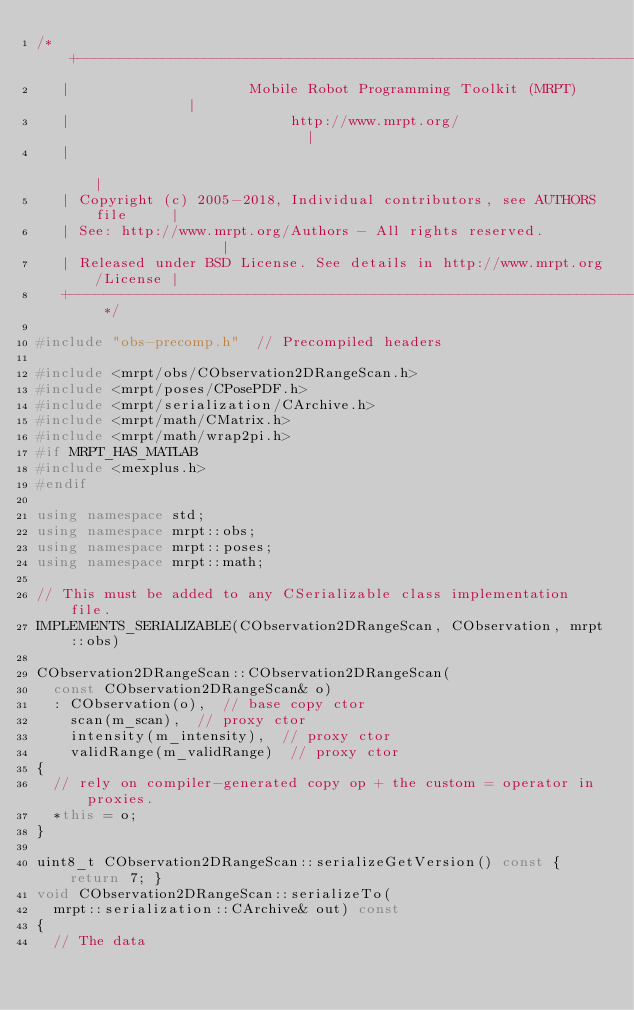Convert code to text. <code><loc_0><loc_0><loc_500><loc_500><_C++_>/* +------------------------------------------------------------------------+
   |                     Mobile Robot Programming Toolkit (MRPT)            |
   |                          http://www.mrpt.org/                          |
   |                                                                        |
   | Copyright (c) 2005-2018, Individual contributors, see AUTHORS file     |
   | See: http://www.mrpt.org/Authors - All rights reserved.                |
   | Released under BSD License. See details in http://www.mrpt.org/License |
   +------------------------------------------------------------------------+ */

#include "obs-precomp.h"  // Precompiled headers

#include <mrpt/obs/CObservation2DRangeScan.h>
#include <mrpt/poses/CPosePDF.h>
#include <mrpt/serialization/CArchive.h>
#include <mrpt/math/CMatrix.h>
#include <mrpt/math/wrap2pi.h>
#if MRPT_HAS_MATLAB
#include <mexplus.h>
#endif

using namespace std;
using namespace mrpt::obs;
using namespace mrpt::poses;
using namespace mrpt::math;

// This must be added to any CSerializable class implementation file.
IMPLEMENTS_SERIALIZABLE(CObservation2DRangeScan, CObservation, mrpt::obs)

CObservation2DRangeScan::CObservation2DRangeScan(
	const CObservation2DRangeScan& o)
	: CObservation(o),  // base copy ctor
	  scan(m_scan),  // proxy ctor
	  intensity(m_intensity),  // proxy ctor
	  validRange(m_validRange)  // proxy ctor
{
	// rely on compiler-generated copy op + the custom = operator in proxies.
	*this = o;
}

uint8_t CObservation2DRangeScan::serializeGetVersion() const { return 7; }
void CObservation2DRangeScan::serializeTo(
	mrpt::serialization::CArchive& out) const
{
	// The data</code> 